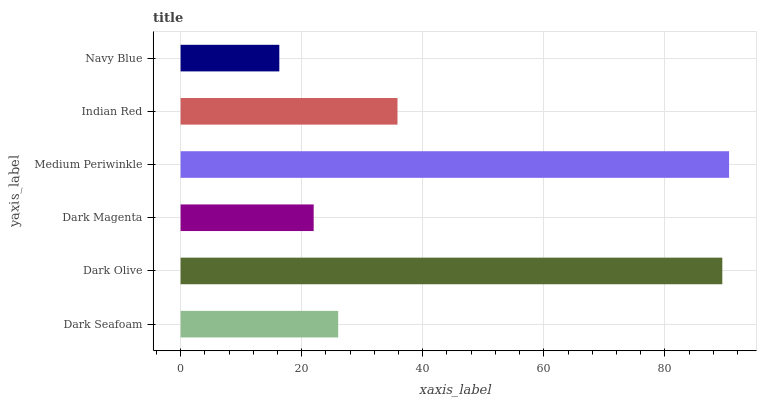Is Navy Blue the minimum?
Answer yes or no. Yes. Is Medium Periwinkle the maximum?
Answer yes or no. Yes. Is Dark Olive the minimum?
Answer yes or no. No. Is Dark Olive the maximum?
Answer yes or no. No. Is Dark Olive greater than Dark Seafoam?
Answer yes or no. Yes. Is Dark Seafoam less than Dark Olive?
Answer yes or no. Yes. Is Dark Seafoam greater than Dark Olive?
Answer yes or no. No. Is Dark Olive less than Dark Seafoam?
Answer yes or no. No. Is Indian Red the high median?
Answer yes or no. Yes. Is Dark Seafoam the low median?
Answer yes or no. Yes. Is Medium Periwinkle the high median?
Answer yes or no. No. Is Dark Olive the low median?
Answer yes or no. No. 